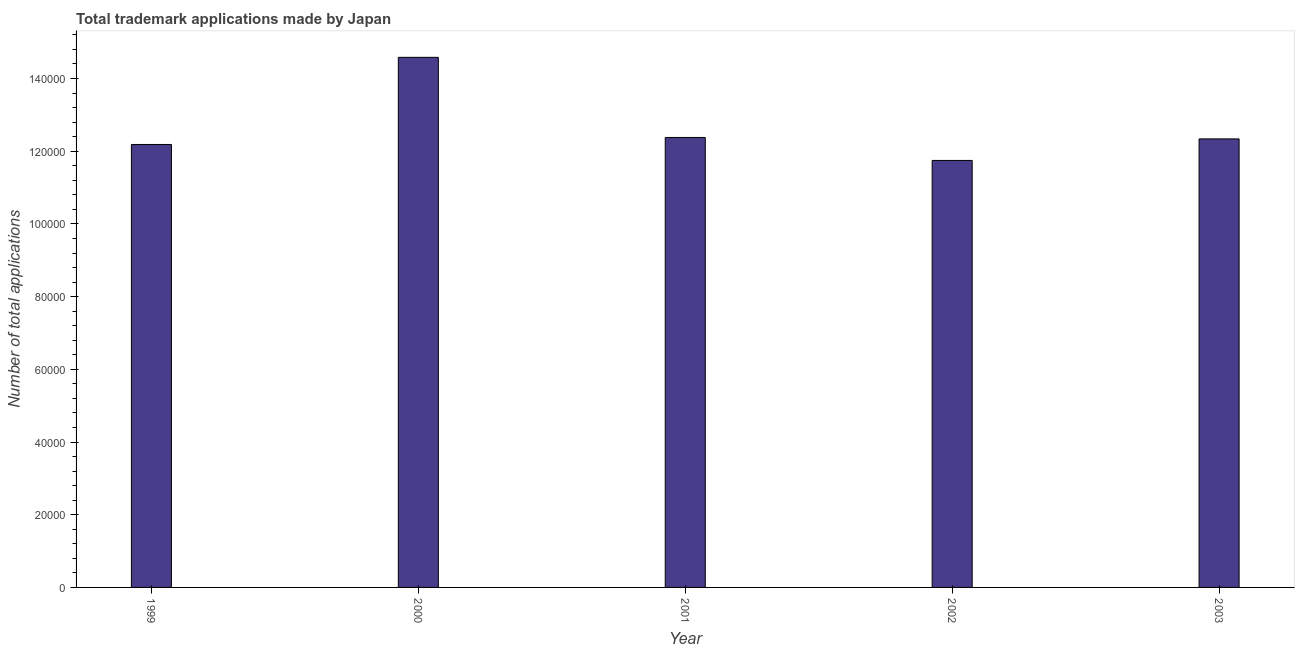Does the graph contain any zero values?
Give a very brief answer. No. Does the graph contain grids?
Keep it short and to the point. No. What is the title of the graph?
Ensure brevity in your answer.  Total trademark applications made by Japan. What is the label or title of the Y-axis?
Your answer should be very brief. Number of total applications. What is the number of trademark applications in 1999?
Provide a succinct answer. 1.22e+05. Across all years, what is the maximum number of trademark applications?
Offer a very short reply. 1.46e+05. Across all years, what is the minimum number of trademark applications?
Provide a short and direct response. 1.17e+05. In which year was the number of trademark applications minimum?
Your answer should be very brief. 2002. What is the sum of the number of trademark applications?
Give a very brief answer. 6.32e+05. What is the difference between the number of trademark applications in 2002 and 2003?
Ensure brevity in your answer.  -5921. What is the average number of trademark applications per year?
Offer a terse response. 1.26e+05. What is the median number of trademark applications?
Ensure brevity in your answer.  1.23e+05. In how many years, is the number of trademark applications greater than 84000 ?
Keep it short and to the point. 5. What is the difference between the highest and the second highest number of trademark applications?
Offer a terse response. 2.20e+04. What is the difference between the highest and the lowest number of trademark applications?
Your answer should be compact. 2.84e+04. In how many years, is the number of trademark applications greater than the average number of trademark applications taken over all years?
Offer a terse response. 1. Are all the bars in the graph horizontal?
Your response must be concise. No. What is the Number of total applications of 1999?
Keep it short and to the point. 1.22e+05. What is the Number of total applications of 2000?
Make the answer very short. 1.46e+05. What is the Number of total applications of 2001?
Ensure brevity in your answer.  1.24e+05. What is the Number of total applications of 2002?
Your answer should be compact. 1.17e+05. What is the Number of total applications in 2003?
Your answer should be very brief. 1.23e+05. What is the difference between the Number of total applications in 1999 and 2000?
Make the answer very short. -2.40e+04. What is the difference between the Number of total applications in 1999 and 2001?
Offer a terse response. -1927. What is the difference between the Number of total applications in 1999 and 2002?
Your response must be concise. 4389. What is the difference between the Number of total applications in 1999 and 2003?
Provide a succinct answer. -1532. What is the difference between the Number of total applications in 2000 and 2001?
Offer a terse response. 2.20e+04. What is the difference between the Number of total applications in 2000 and 2002?
Your answer should be very brief. 2.84e+04. What is the difference between the Number of total applications in 2000 and 2003?
Provide a short and direct response. 2.24e+04. What is the difference between the Number of total applications in 2001 and 2002?
Make the answer very short. 6316. What is the difference between the Number of total applications in 2001 and 2003?
Provide a short and direct response. 395. What is the difference between the Number of total applications in 2002 and 2003?
Keep it short and to the point. -5921. What is the ratio of the Number of total applications in 1999 to that in 2000?
Ensure brevity in your answer.  0.84. What is the ratio of the Number of total applications in 1999 to that in 2001?
Make the answer very short. 0.98. What is the ratio of the Number of total applications in 1999 to that in 2002?
Make the answer very short. 1.04. What is the ratio of the Number of total applications in 1999 to that in 2003?
Give a very brief answer. 0.99. What is the ratio of the Number of total applications in 2000 to that in 2001?
Your answer should be very brief. 1.18. What is the ratio of the Number of total applications in 2000 to that in 2002?
Keep it short and to the point. 1.24. What is the ratio of the Number of total applications in 2000 to that in 2003?
Make the answer very short. 1.18. What is the ratio of the Number of total applications in 2001 to that in 2002?
Ensure brevity in your answer.  1.05. 